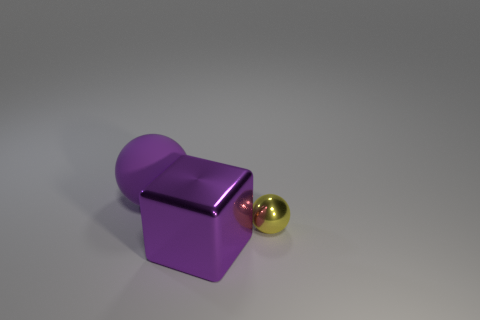Add 2 large metallic balls. How many objects exist? 5 Subtract all blocks. How many objects are left? 2 Subtract 1 blocks. How many blocks are left? 0 Add 3 large shiny objects. How many large shiny objects exist? 4 Subtract 1 yellow spheres. How many objects are left? 2 Subtract all brown cubes. Subtract all gray spheres. How many cubes are left? 1 Subtract all blue cylinders. How many purple spheres are left? 1 Subtract all balls. Subtract all large matte balls. How many objects are left? 0 Add 3 small yellow metallic objects. How many small yellow metallic objects are left? 4 